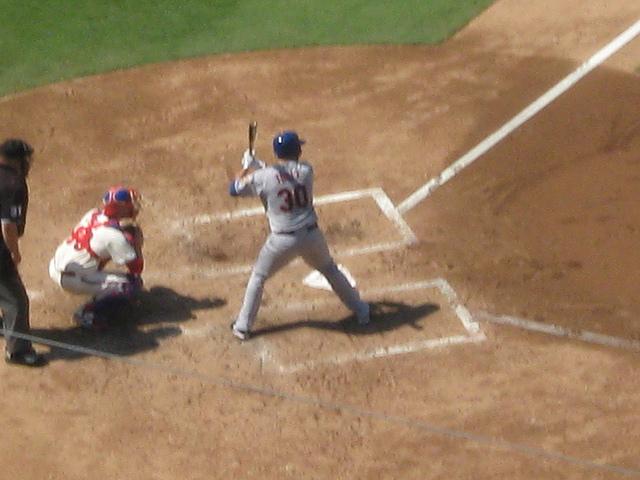What number is on the shirt?
Give a very brief answer. 30. Is this battery left handed?
Answer briefly. Yes. What is the number of people standing?
Concise answer only. 2. What is the batter's number on his shirt?
Write a very short answer. 30. The white lines freshly painted or scuffed?
Give a very brief answer. Scuffed. 